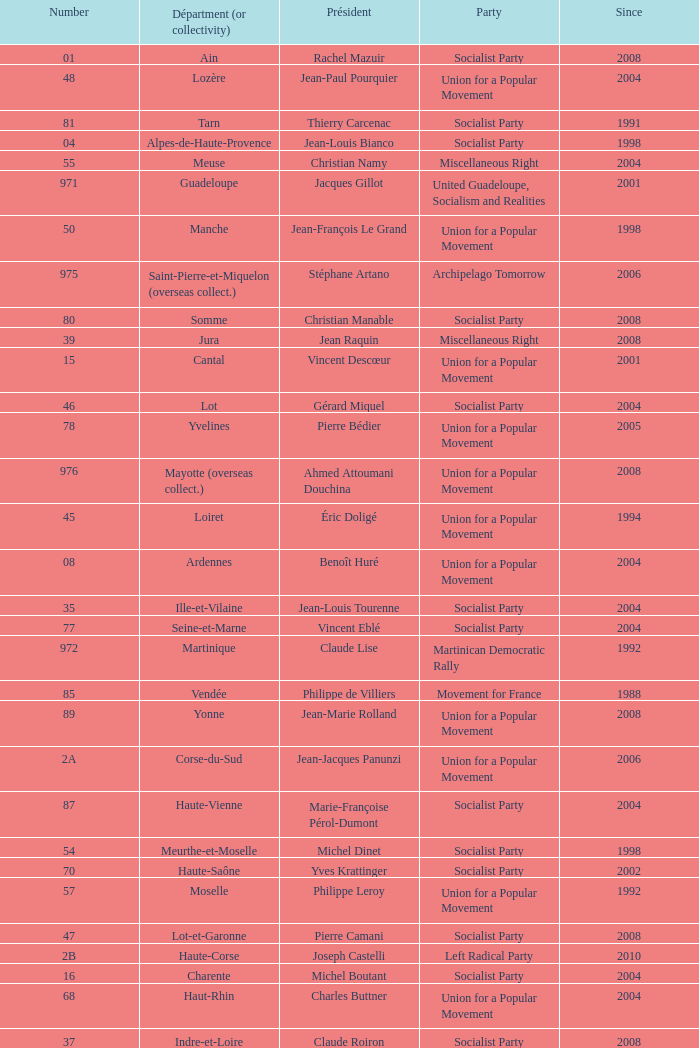Who is the president from the Union for a Popular Movement party that represents the Hautes-Alpes department? Jean-Yves Dusserre. 